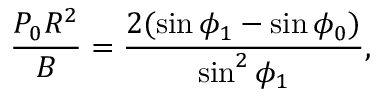<formula> <loc_0><loc_0><loc_500><loc_500>\frac { P _ { 0 } R ^ { 2 } } { B } = \frac { 2 ( \sin \phi _ { 1 } - \sin \phi _ { 0 } ) } { \sin ^ { 2 } \phi _ { 1 } } ,</formula> 